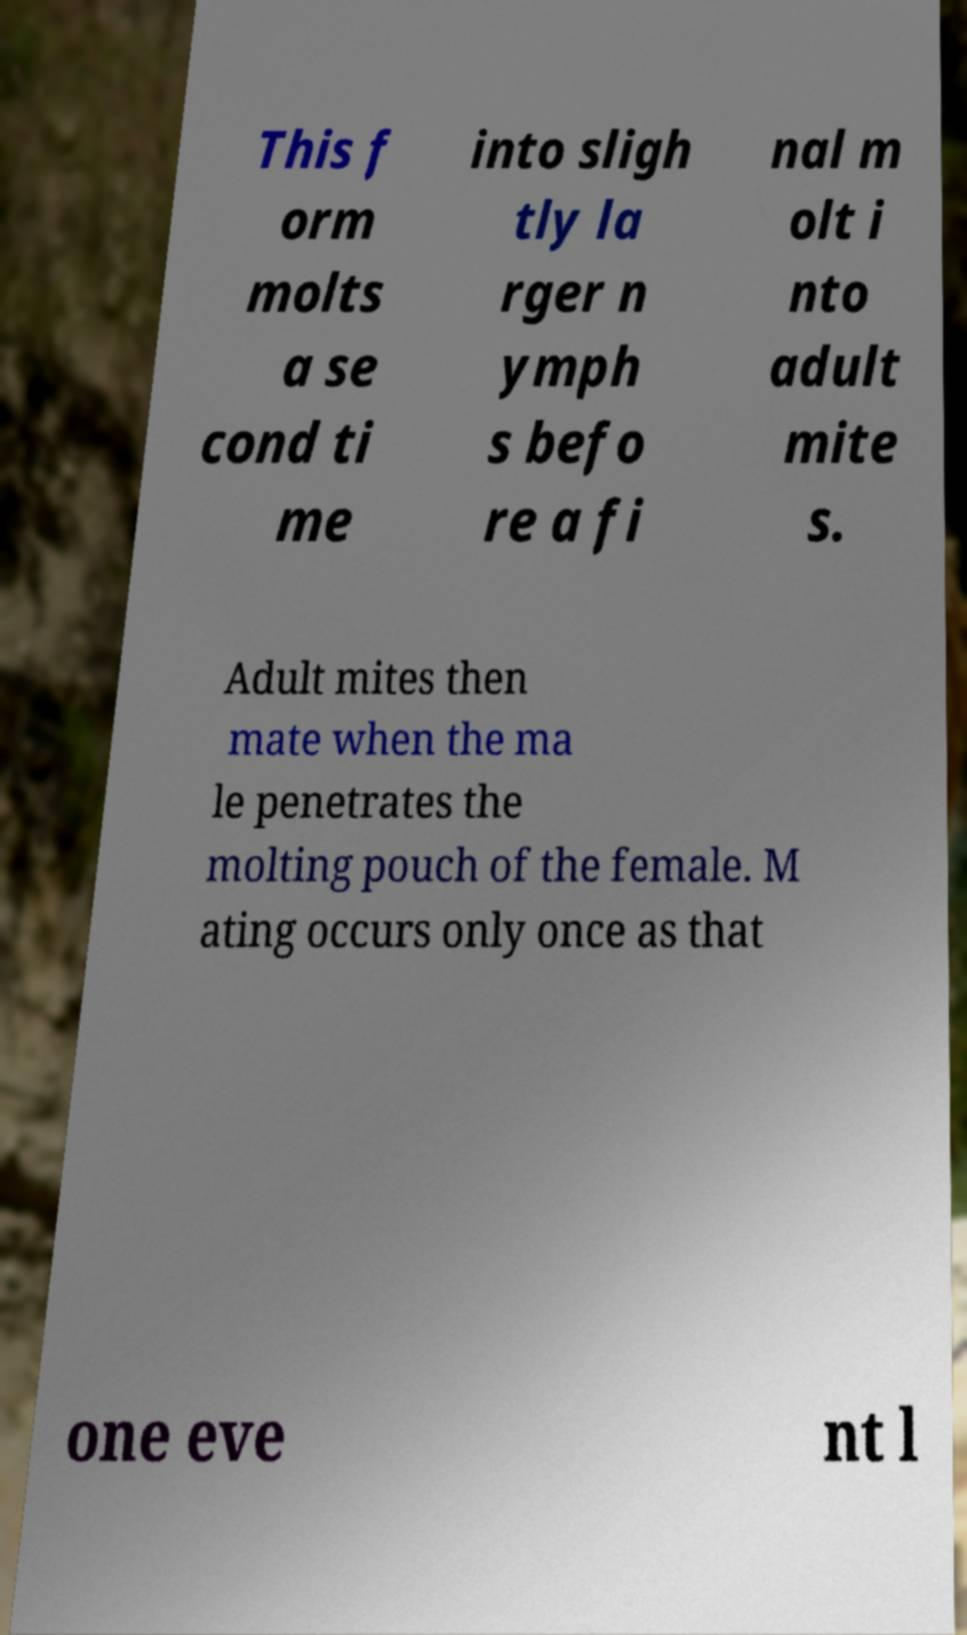Could you assist in decoding the text presented in this image and type it out clearly? This f orm molts a se cond ti me into sligh tly la rger n ymph s befo re a fi nal m olt i nto adult mite s. Adult mites then mate when the ma le penetrates the molting pouch of the female. M ating occurs only once as that one eve nt l 